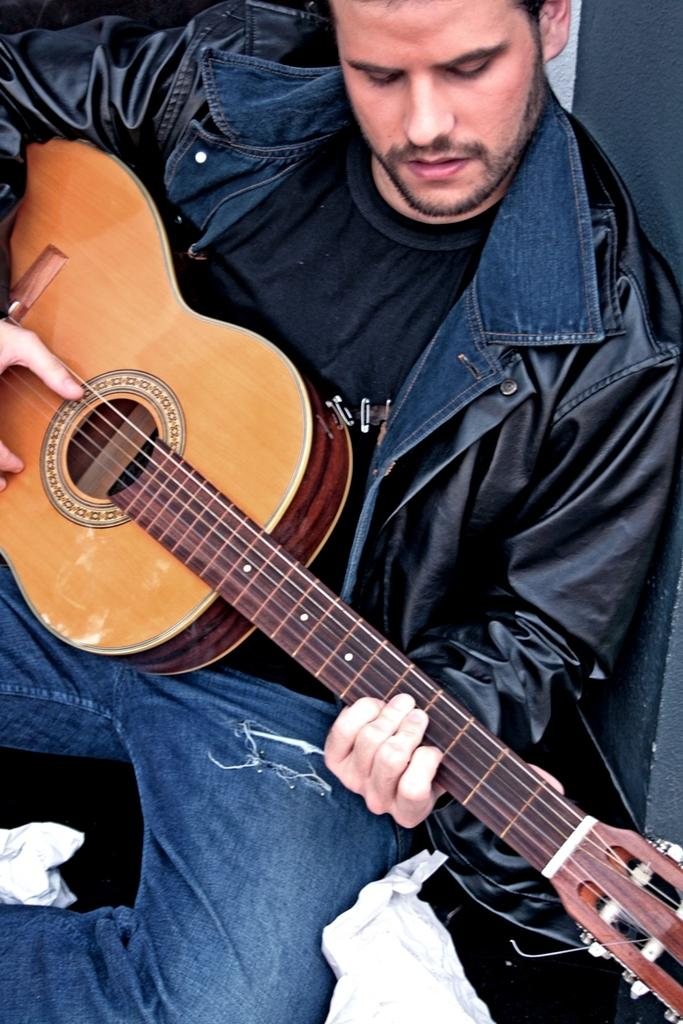Who is the person in the image? There is a man in the image. What is the man doing in the image? The man is sitting on the floor and playing a guitar. What type of twig is the man using to control the air in the image? There is no twig or air control present in the image; the man is playing a guitar. 